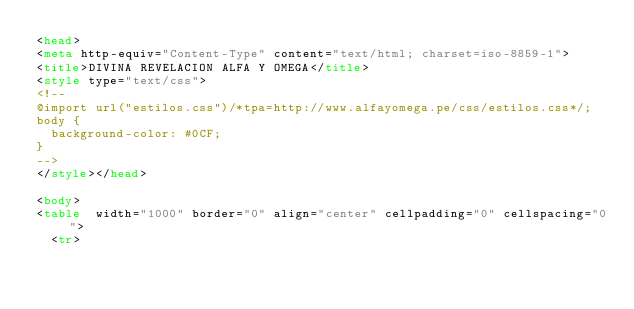<code> <loc_0><loc_0><loc_500><loc_500><_HTML_><head>
<meta http-equiv="Content-Type" content="text/html; charset=iso-8859-1">
<title>DIVINA REVELACION ALFA Y OMEGA</title>
<style type="text/css">
<!--
@import url("estilos.css")/*tpa=http://www.alfayomega.pe/css/estilos.css*/;
body {
	background-color: #0CF;
}
-->
</style></head>

<body>
<table  width="1000" border="0" align="center" cellpadding="0" cellspacing="0">
  <tr></code> 